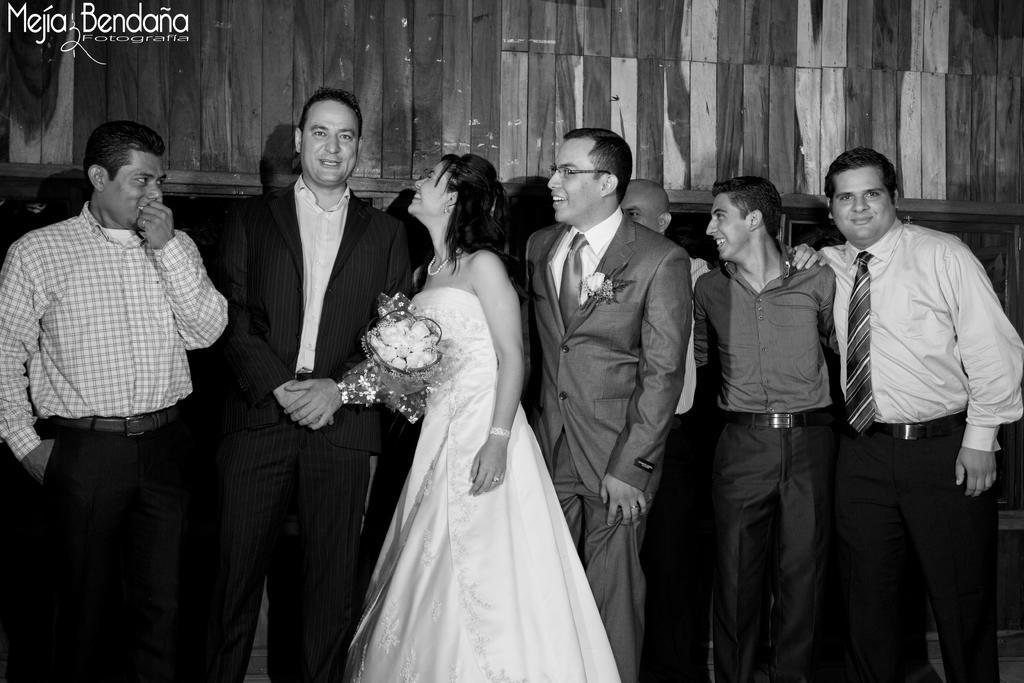Please provide a concise description of this image. In this picture there are group of people standing and smiling and there is a woman with white dress is standing and smiling and she is holding the bouquet. At the back there is a wall. At the top left there is text. 